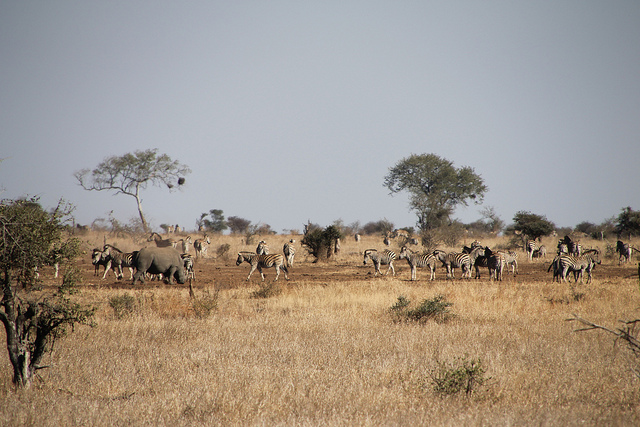What kind of ecosystem is shown in this image, and why is it important? This is a savanna ecosystem, characterized by a mix of trees, shrubs, and grassland. Savannas support a high diversity of wildlife, including grazing herbivores and their predators. They play a crucial role in maintaining biological diversity and offer significant carbon sequestration benefits. 